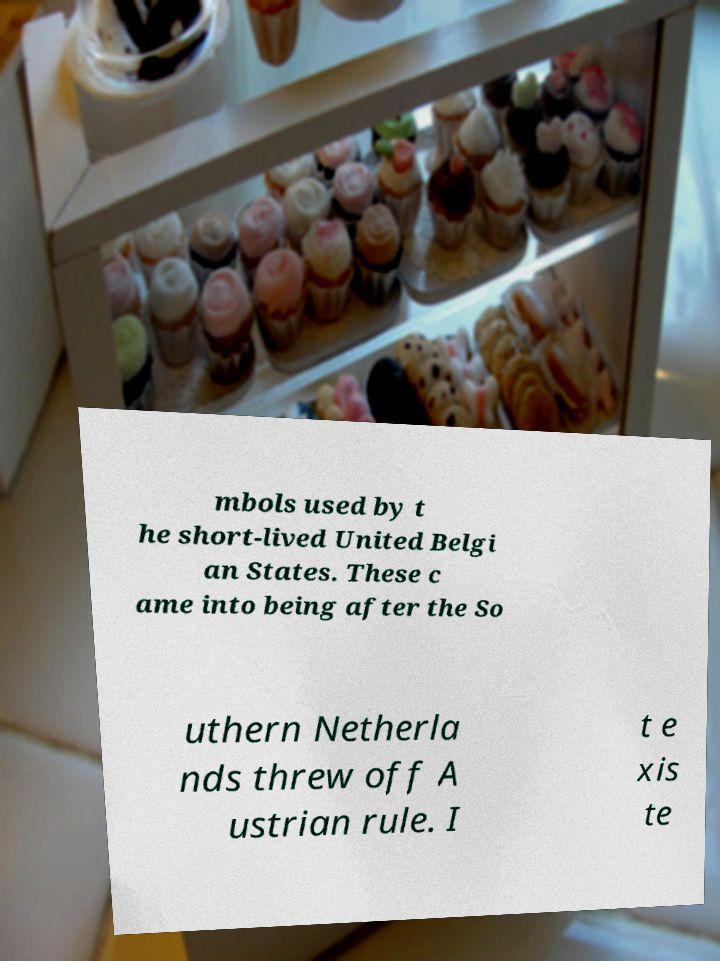For documentation purposes, I need the text within this image transcribed. Could you provide that? mbols used by t he short-lived United Belgi an States. These c ame into being after the So uthern Netherla nds threw off A ustrian rule. I t e xis te 